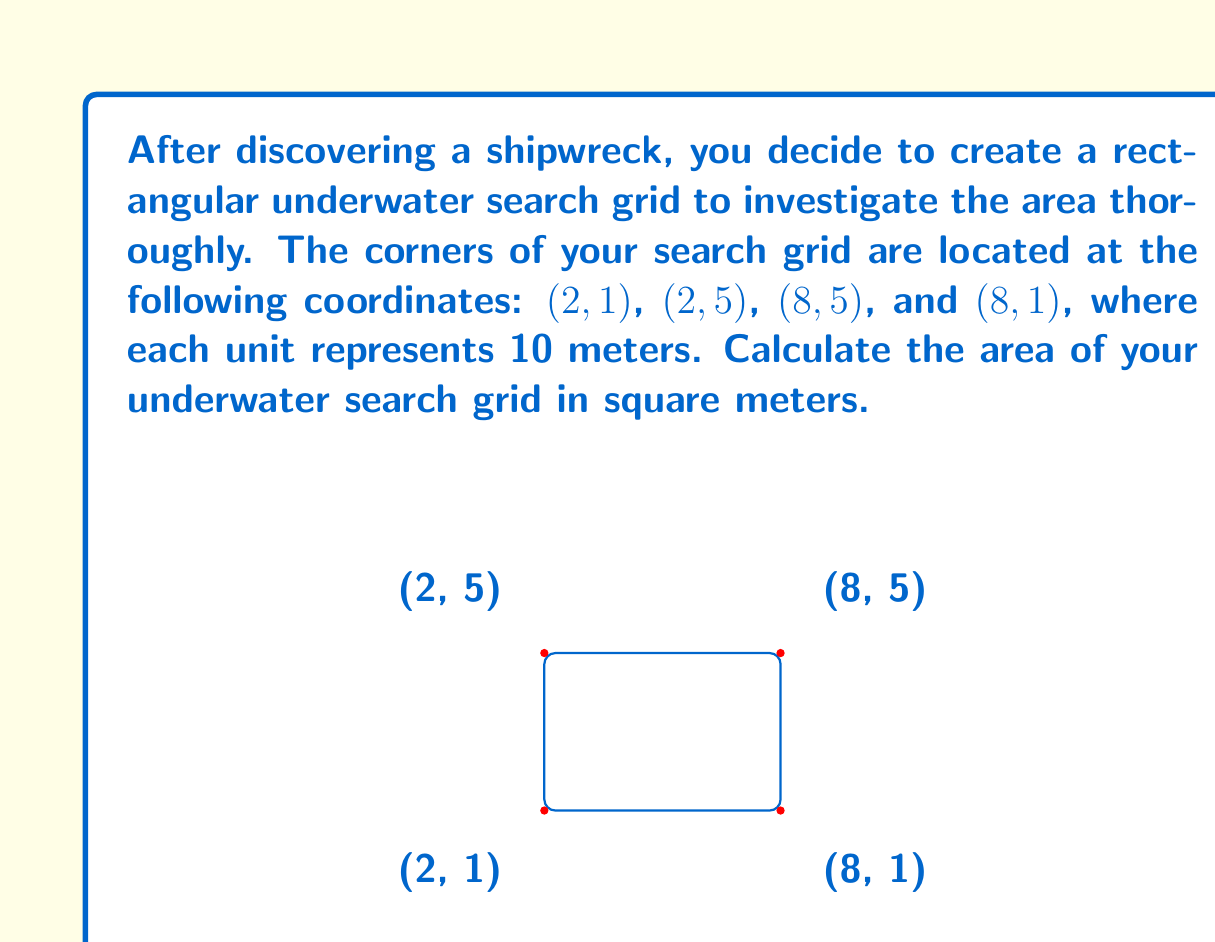Show me your answer to this math problem. To calculate the area of the rectangular underwater search grid, we need to follow these steps:

1) First, let's identify the length and width of the rectangle using the given coordinates.

   Length: The difference between the x-coordinates of the right and left sides.
   $$ \text{Length} = 8 - 2 = 6 \text{ units} $$

   Width: The difference between the y-coordinates of the top and bottom sides.
   $$ \text{Width} = 5 - 1 = 4 \text{ units} $$

2) Now we can calculate the area of the rectangle using the formula:
   $$ \text{Area} = \text{Length} \times \text{Width} $$
   $$ \text{Area} = 6 \times 4 = 24 \text{ square units} $$

3) Remember that each unit represents 10 meters. To convert our area to square meters, we need to multiply by $10^2 = 100$:
   $$ \text{Area in m}^2 = 24 \times 100 = 2400 \text{ m}^2 $$

Therefore, the area of your underwater search grid is 2400 square meters.
Answer: 2400 square meters 